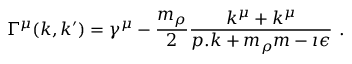Convert formula to latex. <formula><loc_0><loc_0><loc_500><loc_500>\Gamma ^ { \mu } ( k , k ^ { \prime } ) = \gamma ^ { \mu } - \frac { m _ { \rho } } { 2 } \frac { k ^ { \mu } + k ^ { \mu } } { p . k + m _ { \rho } m - \imath \epsilon } \ .</formula> 